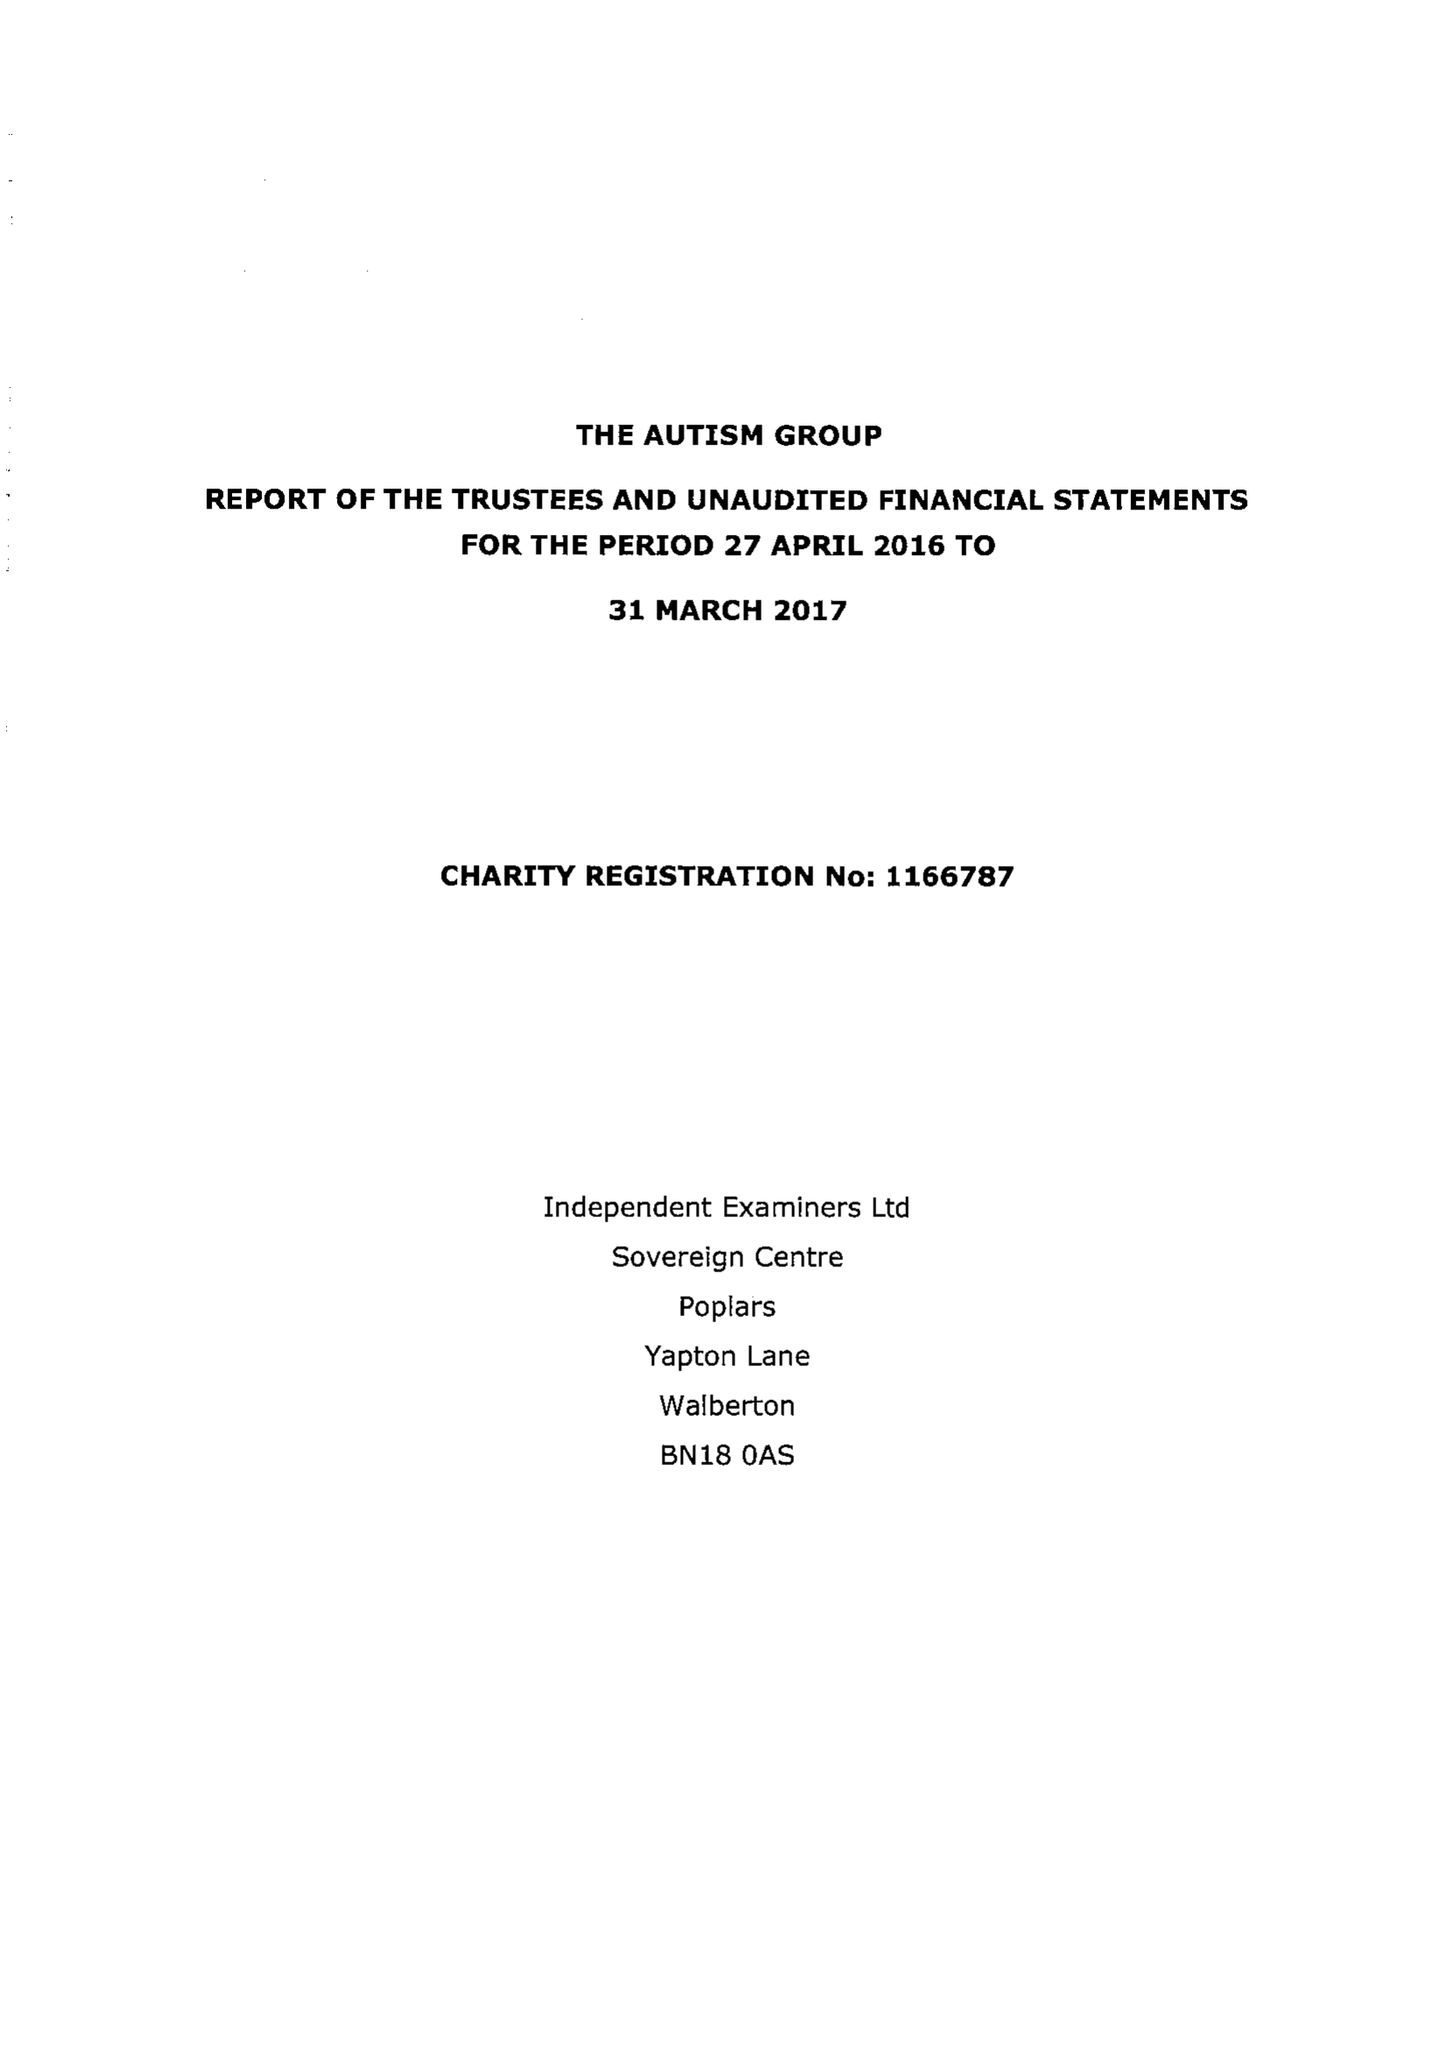What is the value for the address__post_town?
Answer the question using a single word or phrase. MAIDENHEAD 